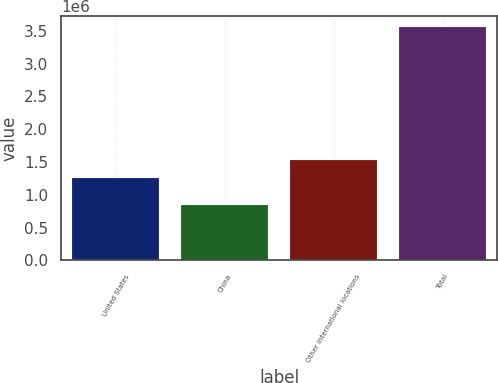<chart> <loc_0><loc_0><loc_500><loc_500><bar_chart><fcel>United States<fcel>China<fcel>Other international locations<fcel>Total<nl><fcel>1.25817e+06<fcel>851626<fcel>1.52841e+06<fcel>3.5541e+06<nl></chart> 